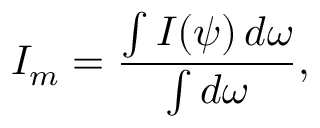<formula> <loc_0><loc_0><loc_500><loc_500>I _ { m } = { \frac { \int I ( \psi ) \, d \omega } { \int d \omega } } ,</formula> 